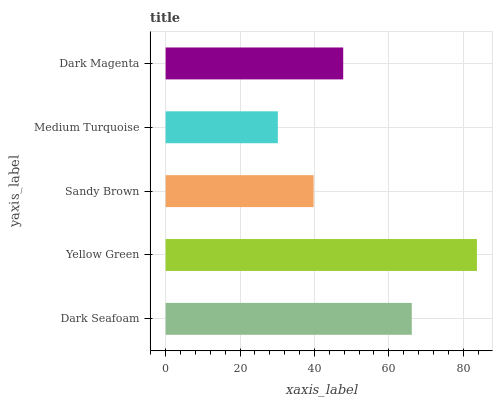Is Medium Turquoise the minimum?
Answer yes or no. Yes. Is Yellow Green the maximum?
Answer yes or no. Yes. Is Sandy Brown the minimum?
Answer yes or no. No. Is Sandy Brown the maximum?
Answer yes or no. No. Is Yellow Green greater than Sandy Brown?
Answer yes or no. Yes. Is Sandy Brown less than Yellow Green?
Answer yes or no. Yes. Is Sandy Brown greater than Yellow Green?
Answer yes or no. No. Is Yellow Green less than Sandy Brown?
Answer yes or no. No. Is Dark Magenta the high median?
Answer yes or no. Yes. Is Dark Magenta the low median?
Answer yes or no. Yes. Is Yellow Green the high median?
Answer yes or no. No. Is Yellow Green the low median?
Answer yes or no. No. 